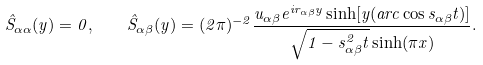Convert formula to latex. <formula><loc_0><loc_0><loc_500><loc_500>\hat { S } _ { \alpha \alpha } ( y ) = 0 , \quad \hat { S } _ { \alpha \beta } ( y ) = ( 2 \pi ) ^ { - 2 } \frac { u _ { \alpha \beta } e ^ { i r _ { \alpha \beta } y } \sinh [ y ( a r c \cos s _ { \alpha \beta } t ) ] } { \sqrt { 1 - s _ { \alpha \beta } ^ { 2 } t } \sinh ( \pi x ) } .</formula> 